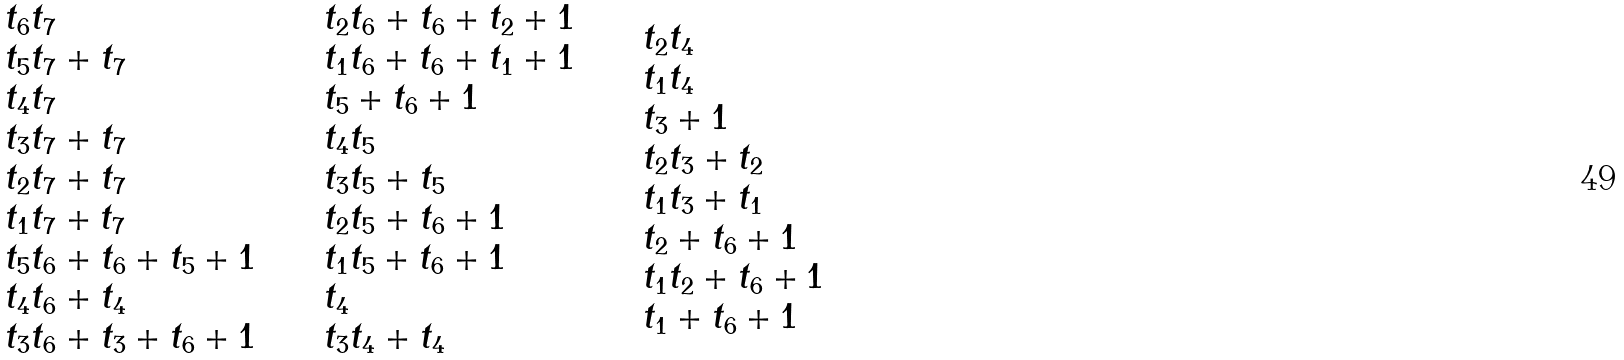<formula> <loc_0><loc_0><loc_500><loc_500>\begin{array} { l l l l l l l } \begin{array} { l } t _ { 6 } t _ { 7 } \\ t _ { 5 } t _ { 7 } + t _ { 7 } \\ t _ { 4 } t _ { 7 } \\ t _ { 3 } t _ { 7 } + t _ { 7 } \\ t _ { 2 } t _ { 7 } + t _ { 7 } \\ t _ { 1 } t _ { 7 } + t _ { 7 } \\ t _ { 5 } t _ { 6 } + t _ { 6 } + t _ { 5 } + 1 \\ t _ { 4 } t _ { 6 } + t _ { 4 } \\ t _ { 3 } t _ { 6 } + t _ { 3 } + t _ { 6 } + 1 \end{array} & & & \begin{array} { l } t _ { 2 } t _ { 6 } + t _ { 6 } + t _ { 2 } + 1 \\ t _ { 1 } t _ { 6 } + t _ { 6 } + t _ { 1 } + 1 \\ t _ { 5 } + t _ { 6 } + 1 \\ t _ { 4 } t _ { 5 } \\ t _ { 3 } t _ { 5 } + t _ { 5 } \\ t _ { 2 } t _ { 5 } + t _ { 6 } + 1 \\ t _ { 1 } t _ { 5 } + t _ { 6 } + 1 \\ t _ { 4 } \\ t _ { 3 } t _ { 4 } + t _ { 4 } \end{array} & & & \begin{array} { l } t _ { 2 } t _ { 4 } \\ t _ { 1 } t _ { 4 } \\ t _ { 3 } + 1 \\ t _ { 2 } t _ { 3 } + t _ { 2 } \\ t _ { 1 } t _ { 3 } + t _ { 1 } \\ t _ { 2 } + t _ { 6 } + 1 \\ t _ { 1 } t _ { 2 } + t _ { 6 } + 1 \\ t _ { 1 } + t _ { 6 } + 1 \end{array} \end{array}</formula> 